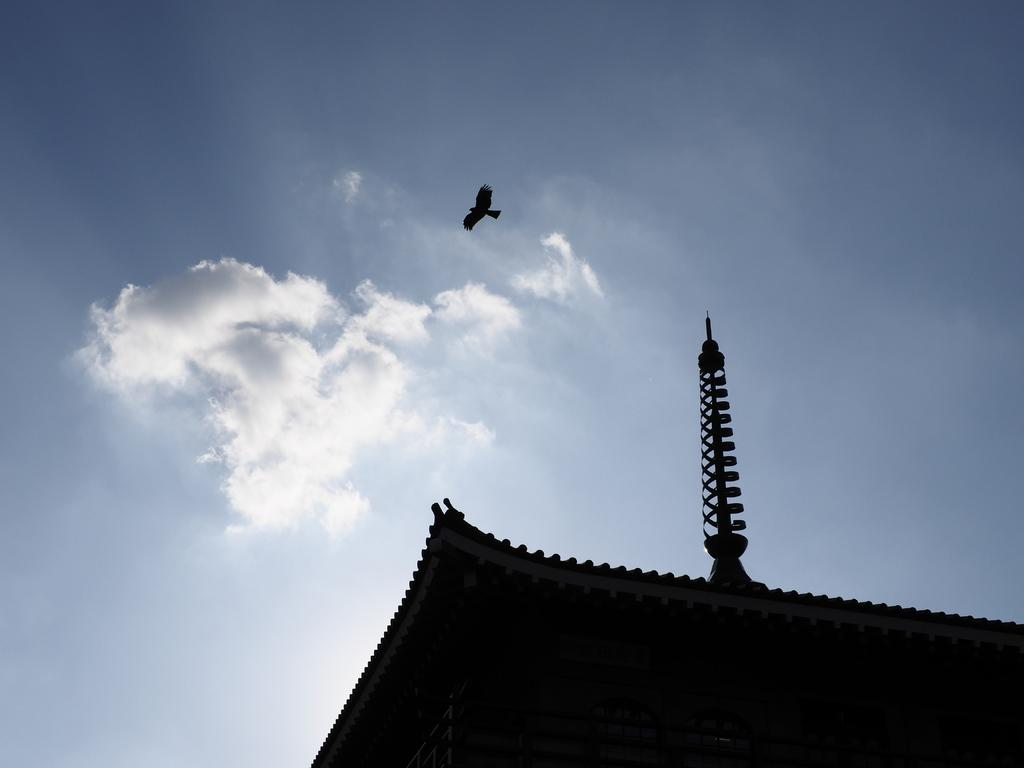What type of structure is visible in the image? There is a shed tent in the image. What can be seen in the sky in the image? An eagle is flying in the sky in the image. What type of slip is the eagle wearing on its arm in the image? There is no slip or arm visible on the eagle in the image; it is a bird flying in the sky. 